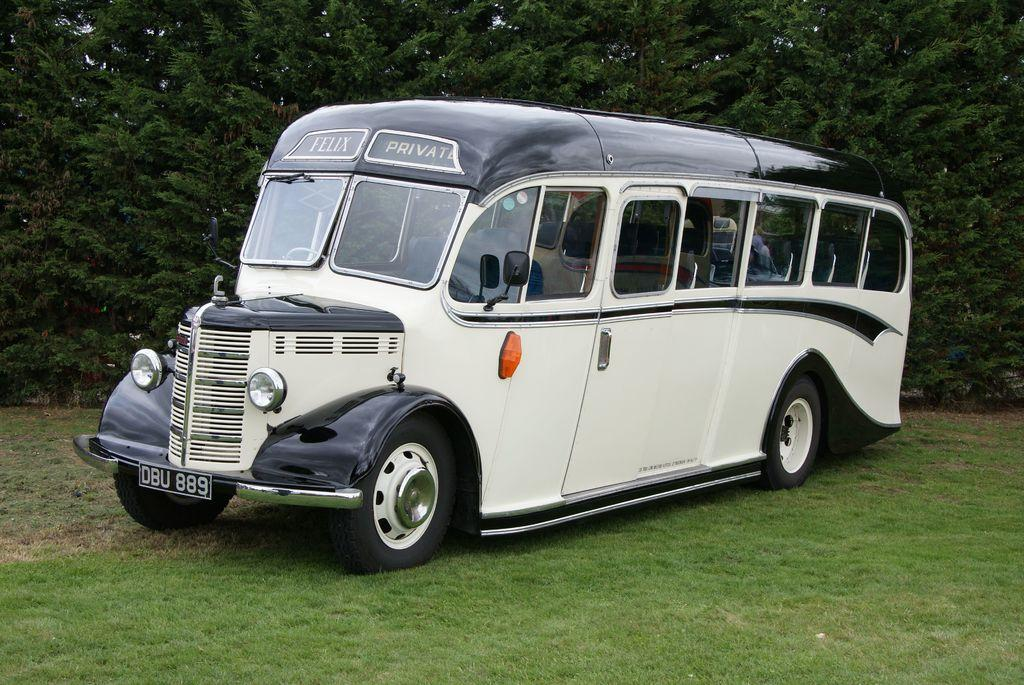<image>
Summarize the visual content of the image. A classic vehicle that looks like it is a cross between a bus and a van has the words Felix Private over the windshield. 